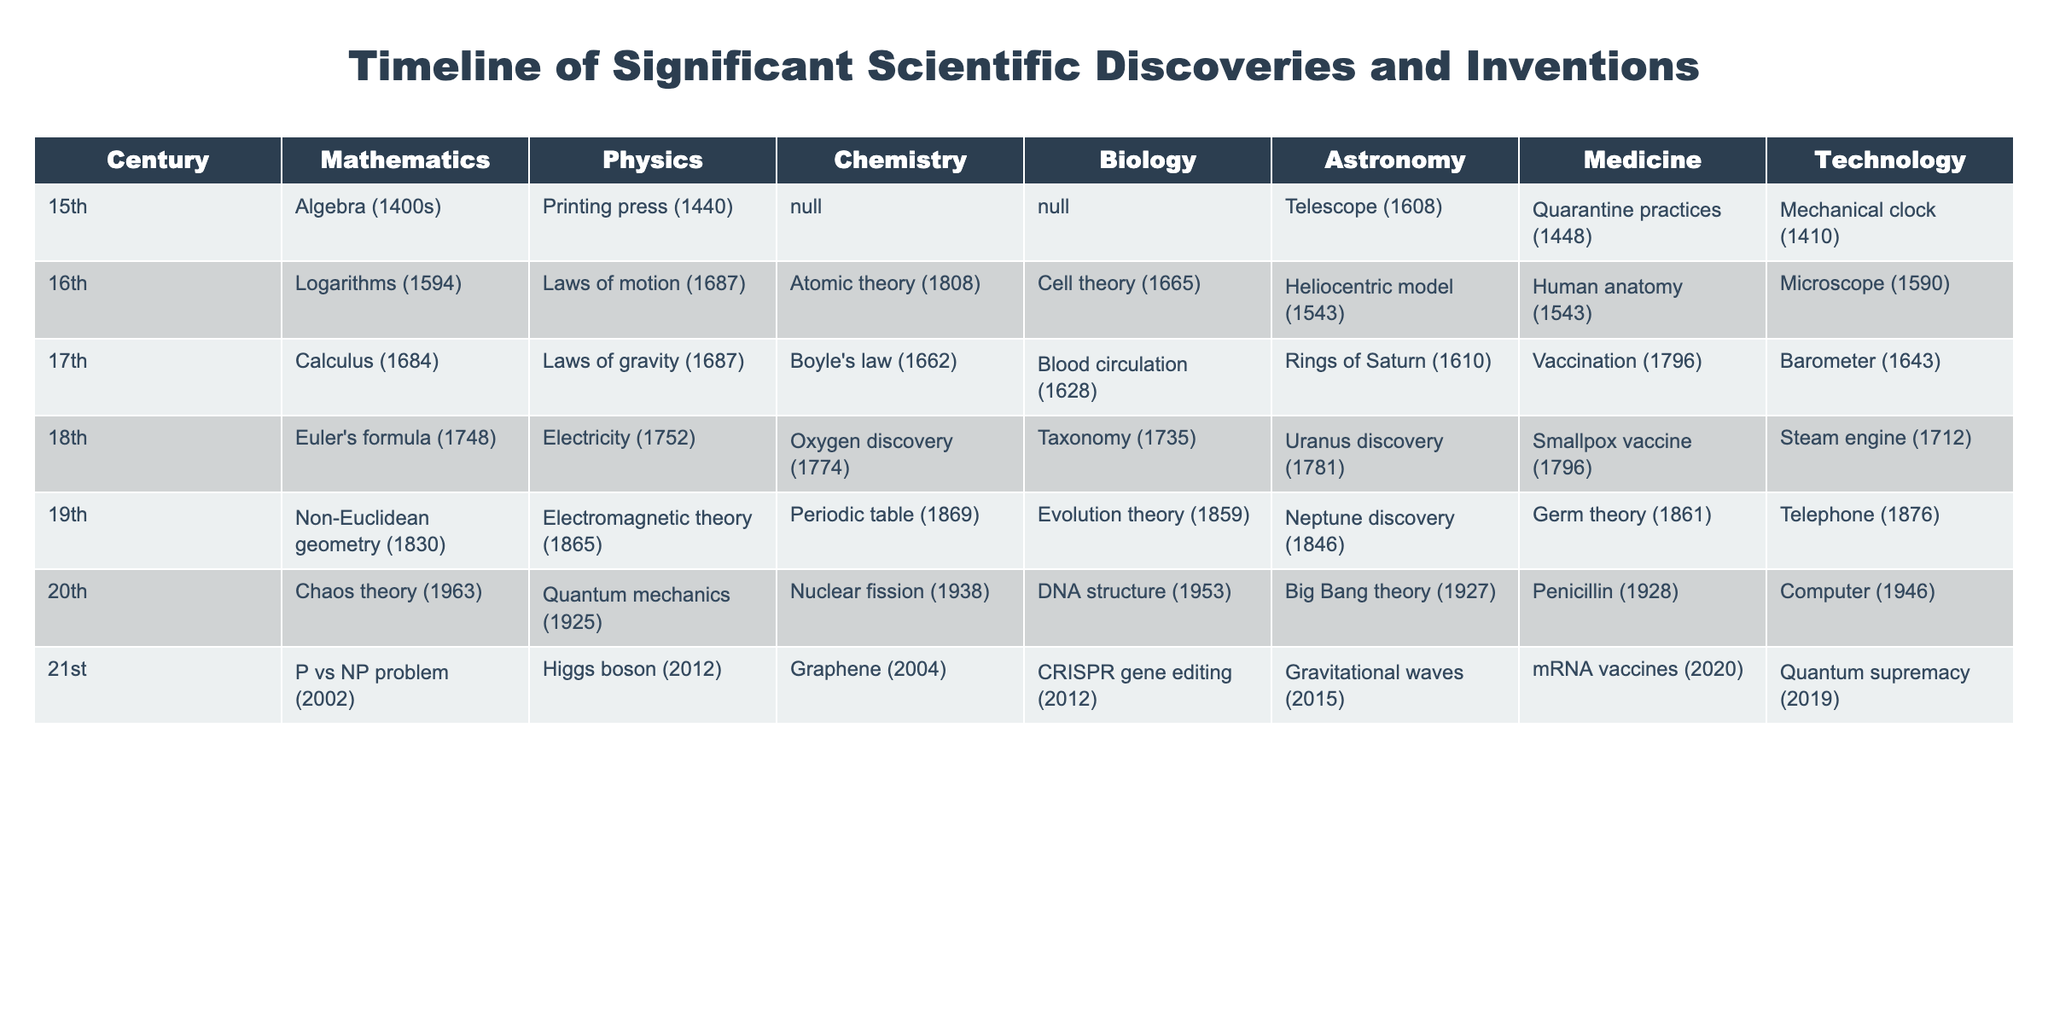What significant mathematical discovery was made in the 17th century? Referring to the table, in the 17th century under the Mathematics column, the significant discovery listed is Calculus, made in 1684.
Answer: Calculus Which century saw the invention of the printing press? The printing press was invented in 1440, and that date falls within the 15th century, as indicated by the table.
Answer: 15th century Was the periodic table discovered before the theory of evolution? The periodic table was discovered in 1869, while the theory of evolution was proposed in 1859. Since 1869 is after 1859, the statement is false.
Answer: No In which century did the discovery of DNA structure occur? According to the table, the structure of DNA was discovered in 1953, which falls within the 20th century.
Answer: 20th century Identify the scientific area that had its first significant discovery in the 21st century. By analyzing the table, the first listed discovery in the 21st century in the Technology category is Quantum supremacy, made in 2019.
Answer: Technology How many significant discoveries in Biology were made before the 18th century? The table lists three significant discoveries in Biology prior to the 18th century: Blood circulation (1628), Cell theory (1665), and Human Anatomy (1543). Hence, there are three discoveries.
Answer: 3 Which discovery in Astronomy occurred in the 19th century? The table indicates that Neptune was discovered in 1846, which is listed under the Astronomy column for the 19th century.
Answer: Neptune discovery List all the significant discoveries in Mathematics from the 15th to the 18th century. Looking at the table, the discoveries are: Algebra (15th century), Logarithms (16th century), Calculus (17th century), and Euler's formula (18th century). Compiling these, we get the four discoveries.
Answer: Algebra, Logarithms, Calculus, Euler's formula Was the Higgs boson discovered before the P vs NP problem? The table shows that the Higgs boson was discovered in 2012 and the P vs NP problem was posited in 2002. Since 2012 is after 2002, this question's answer is false.
Answer: No What is the latest significant invention in Technology listed in the table? According to the table, the latest significant invention in Technology is Quantum supremacy, recorded in 2019.
Answer: Quantum supremacy How many scientific discoveries are listed for the 19th century across all categories? From the table, the significant discoveries across all categories in the 19th century include: Non-Euclidean geometry (Mathematics), Electromagnetic theory (Physics), Periodic table (Chemistry), Evolution theory (Biology), Neptune discovery (Astronomy), and Germ theory (Medicine). This totals to six discoveries.
Answer: 6 